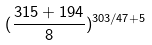<formula> <loc_0><loc_0><loc_500><loc_500>( \frac { 3 1 5 + 1 9 4 } { 8 } ) ^ { 3 0 3 / 4 7 + 5 }</formula> 